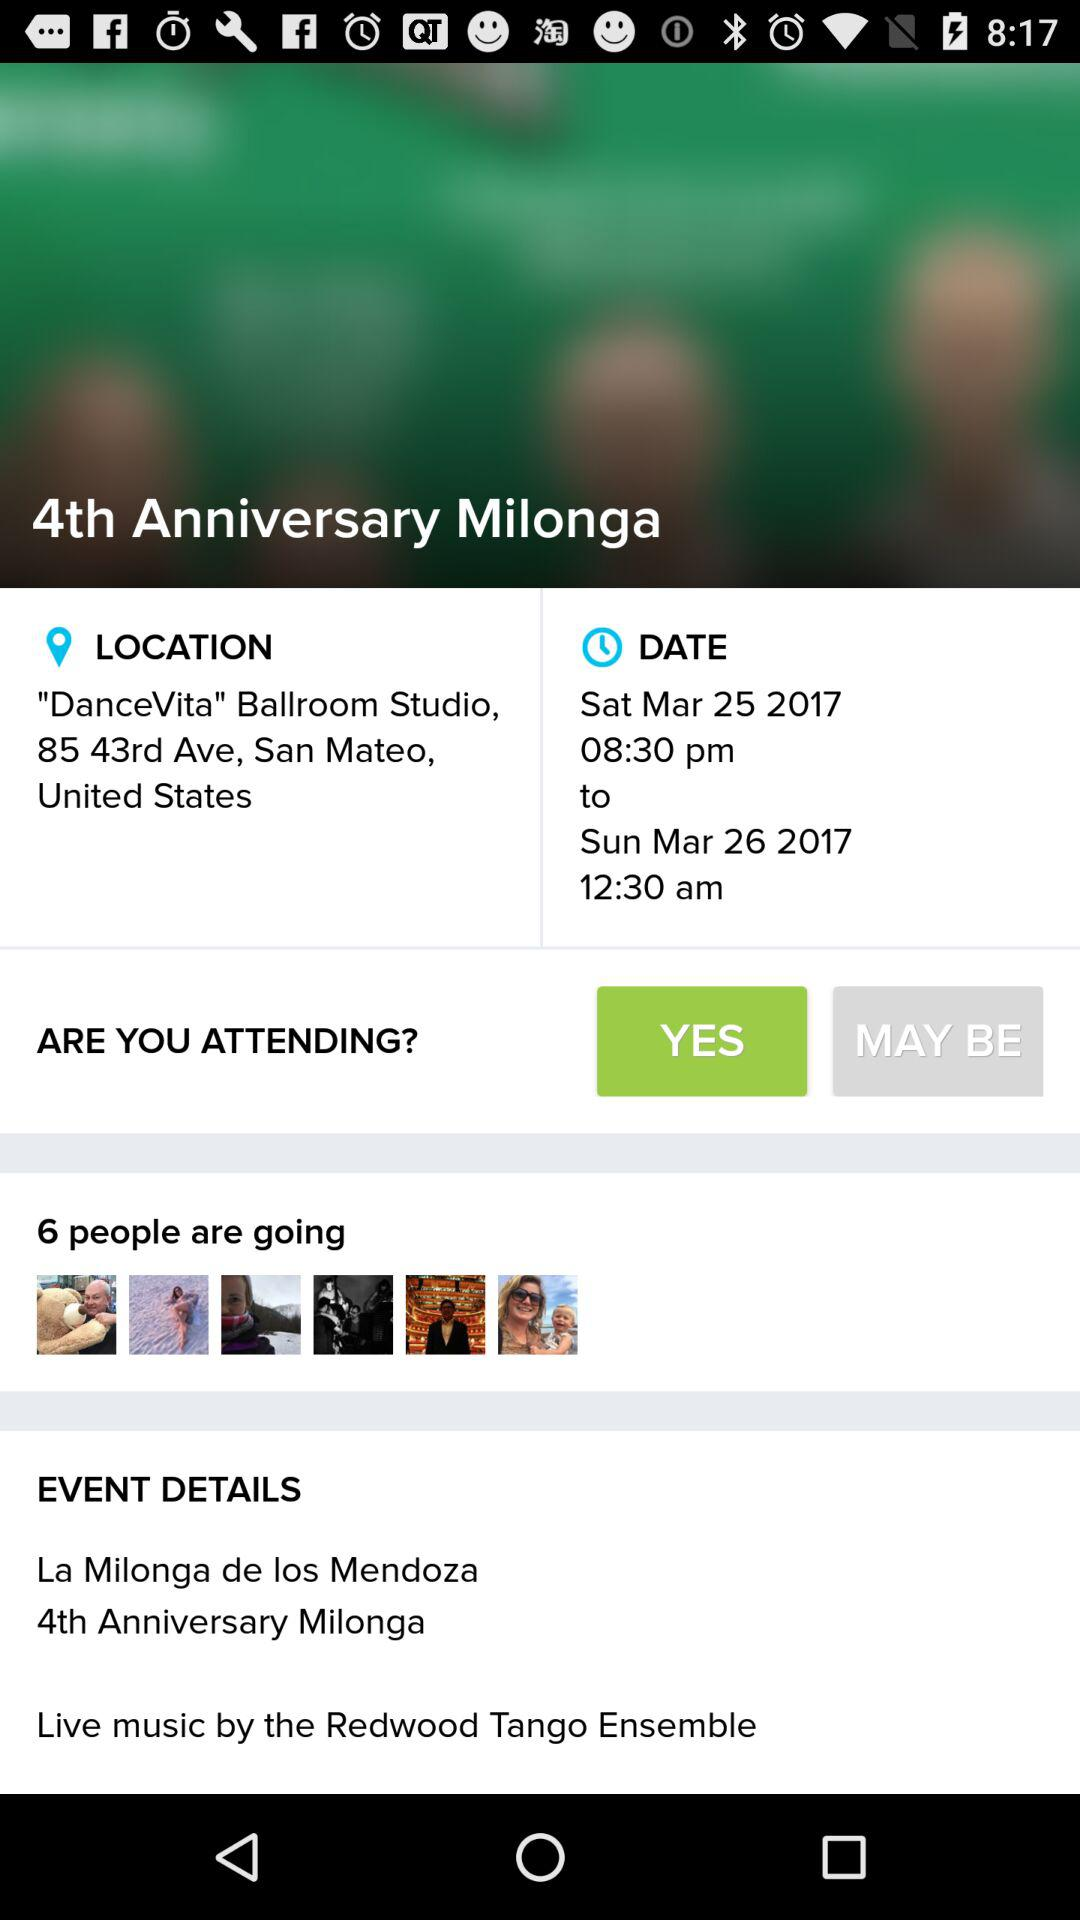What is the boutique name? It is "Rancho Solano Spring Fling Boutique". 